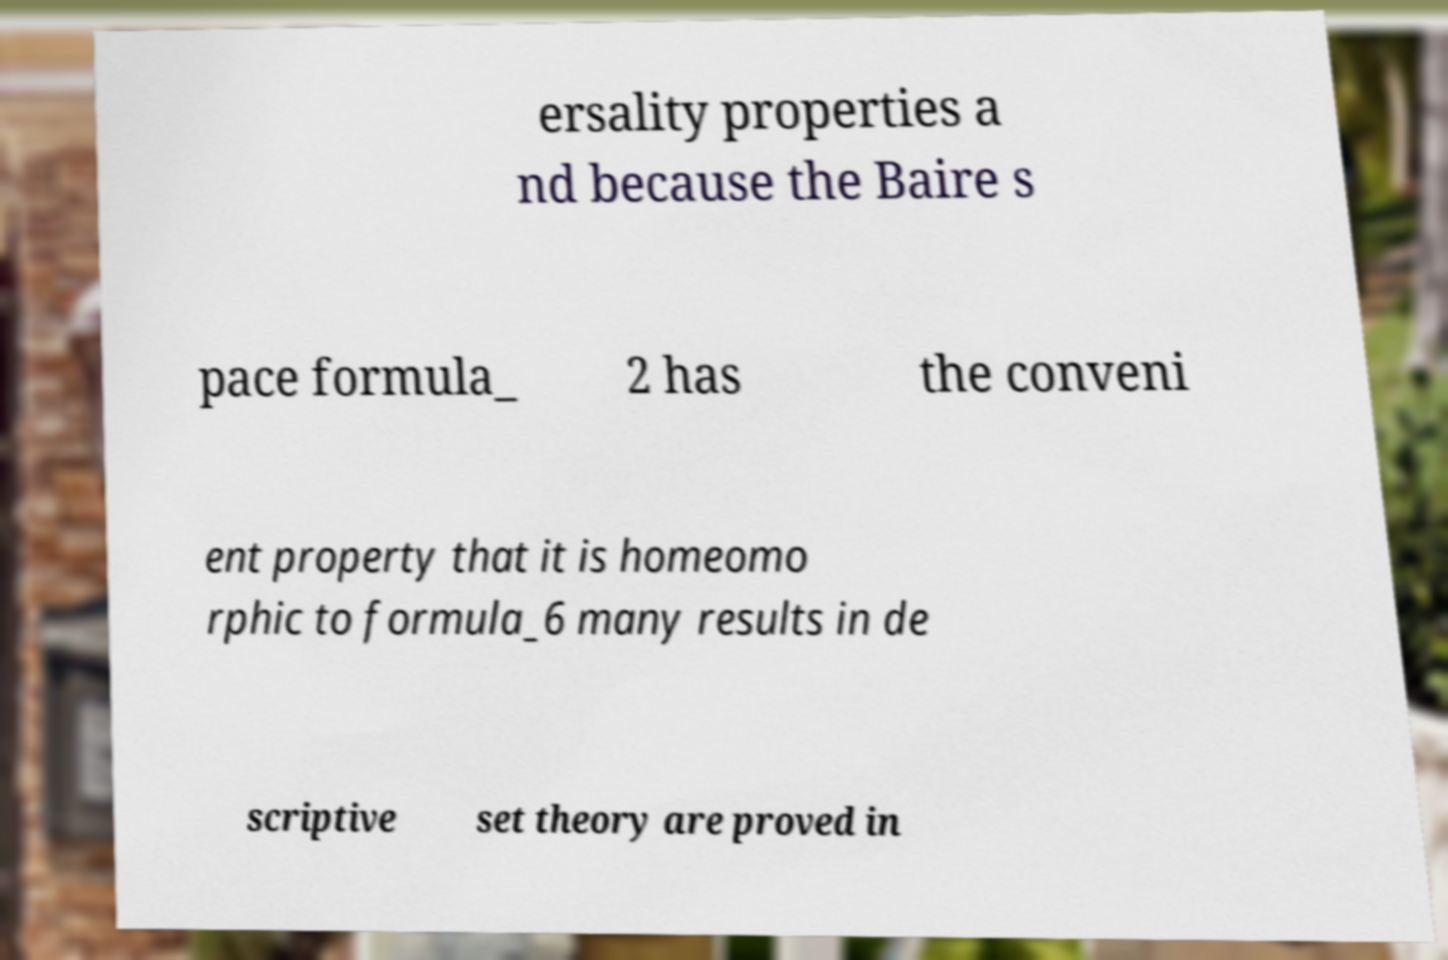For documentation purposes, I need the text within this image transcribed. Could you provide that? ersality properties a nd because the Baire s pace formula_ 2 has the conveni ent property that it is homeomo rphic to formula_6 many results in de scriptive set theory are proved in 